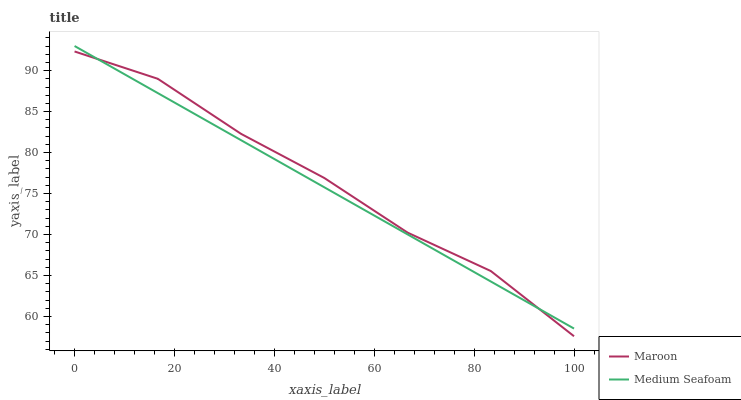Does Medium Seafoam have the minimum area under the curve?
Answer yes or no. Yes. Does Maroon have the maximum area under the curve?
Answer yes or no. Yes. Does Maroon have the minimum area under the curve?
Answer yes or no. No. Is Medium Seafoam the smoothest?
Answer yes or no. Yes. Is Maroon the roughest?
Answer yes or no. Yes. Is Maroon the smoothest?
Answer yes or no. No. Does Maroon have the lowest value?
Answer yes or no. Yes. Does Medium Seafoam have the highest value?
Answer yes or no. Yes. Does Maroon have the highest value?
Answer yes or no. No. Does Medium Seafoam intersect Maroon?
Answer yes or no. Yes. Is Medium Seafoam less than Maroon?
Answer yes or no. No. Is Medium Seafoam greater than Maroon?
Answer yes or no. No. 